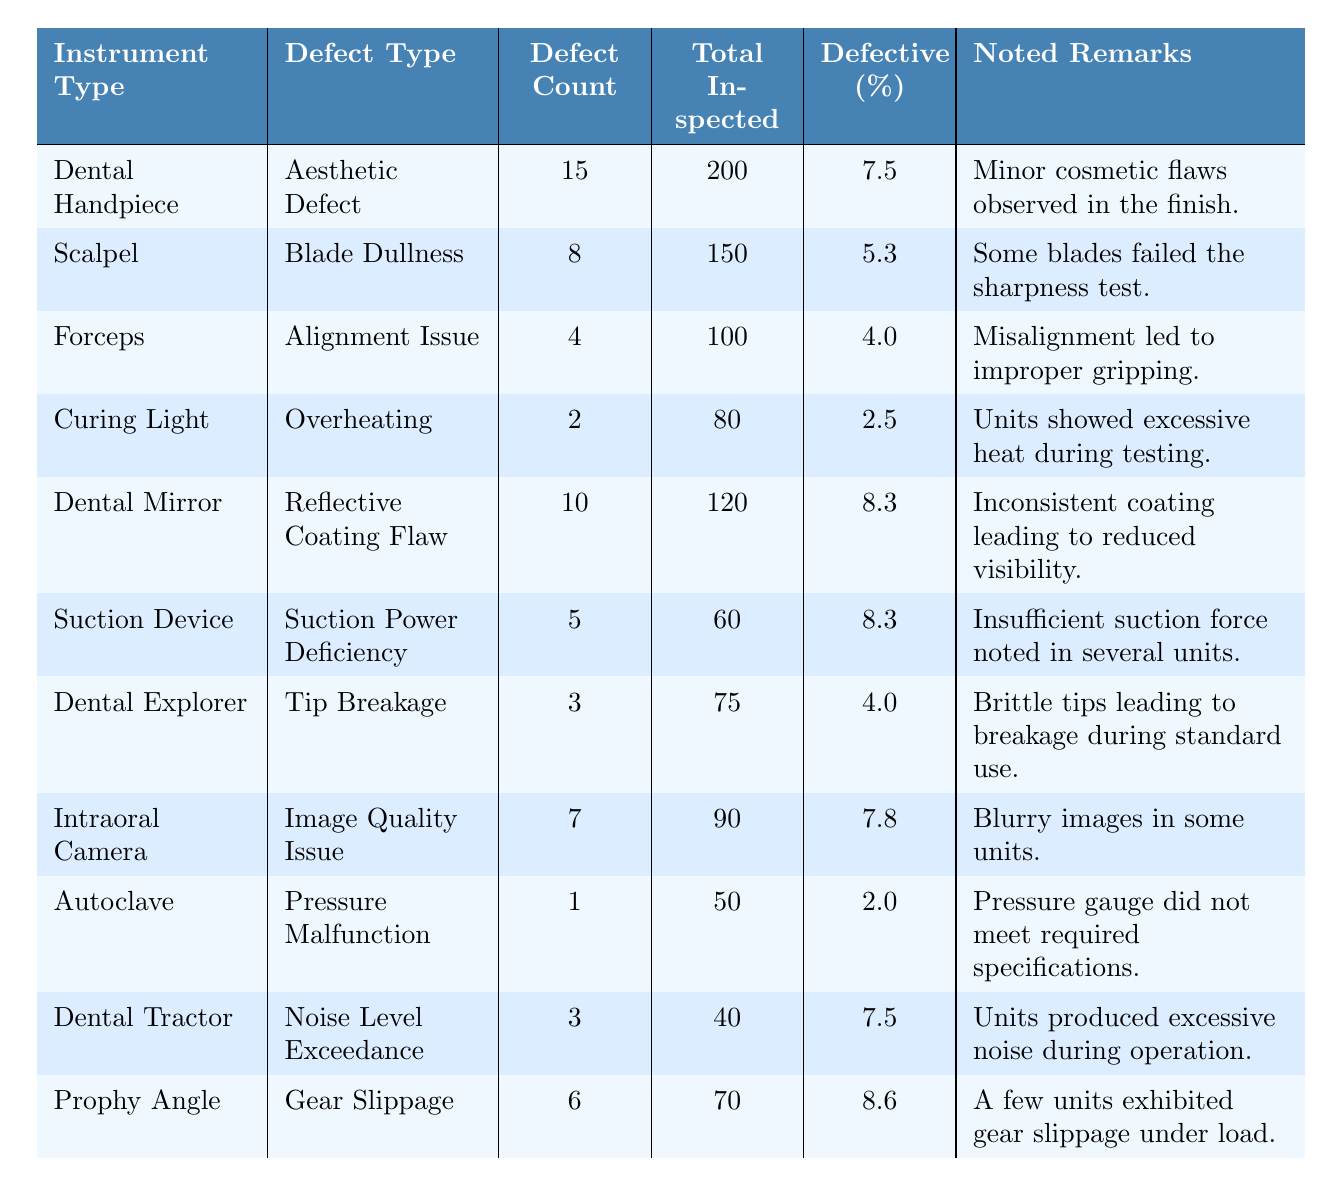What is the defect count for the Curing Light? The table shows that the defect count for the Curing Light is listed directly under the "Defect Count" column, which corresponds to this instrument type. The value is 2.
Answer: 2 Which instrument type has the highest percentage of defects? By comparing the "Defective (%)" values, the Prophy Angle has a defect percentage of 8.6, which is the highest among all instrument types listed.
Answer: Prophy Angle How many instruments were inspected in total for the Dental Handpiece? The total number of inspected units for the Dental Handpiece can be found in the "Total Inspected" column corresponding to this instrument type, which shows a value of 200.
Answer: 200 What is the average percentage of defects across all instrument types? To calculate the average, I will sum the defect percentages of all instruments: (7.5 + 5.3 + 4.0 + 2.5 + 8.3 + 8.3 + 4.0 + 7.8 + 2.0 + 7.5 + 8.6) = 58.5, and then divide by the total number of instruments (11): 58.5 / 11 = 5.32.
Answer: 5.32 Is there an instrument type with a defect count of 1? Reviewing the defect counts listed, the Autoclave has a defect count of 1, as noted in the "Defect Count" column for this instrument type.
Answer: Yes How many instruments are categorized under aesthetic defects? The only instrument type categorized as having aesthetic defects is the Dental Handpiece, which has been noted specifically in the table.
Answer: 1 What is the total defect count for instruments with overheating issues? The only instrument type listed with overheating issues is the Curing Light, which has a defect count of 2. Therefore, the total defect count for that category is also 2.
Answer: 2 Which instrument type showed excessive noise during operation? The table specifically notes that the Dental Tractor produced excessive noise during operation as per the "Noted Remarks" for that instrument type.
Answer: Dental Tractor How many total defects were recorded for Forceps and Dental Explorer combined? To find this, I will add the defect counts for both the Forceps (4) and the Dental Explorer (3): 4 + 3 = 7.
Answer: 7 Is the defect percentage for the Scalpel greater than 6%? The defect percentage for the Scalpel is 5.3%, which is less than 6%. Therefore, the answer to this question is based on a comparison.
Answer: No 